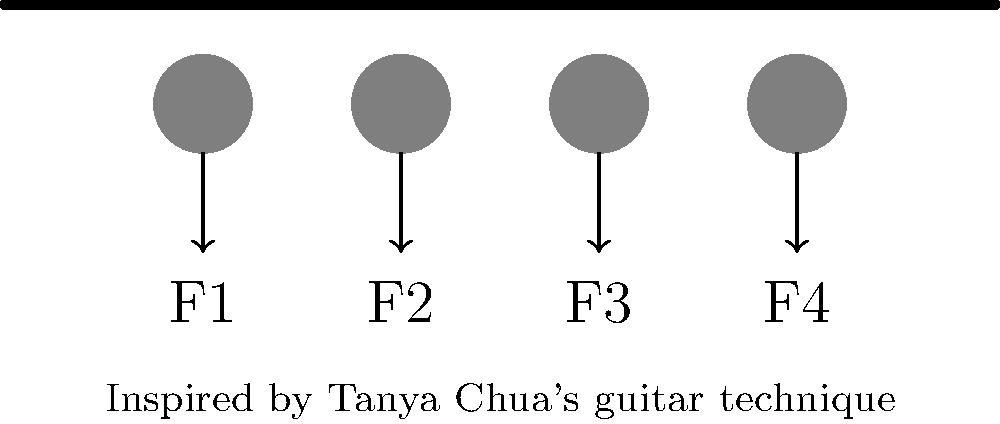In this simplified diagram of a hand position while playing guitar, inspired by Tanya Chua's technique, four fingers are pressing down on the strings. If the total force applied by the hand is 20N, and the force distribution follows the sequence of a geometric progression with a common ratio of 1.5, what is the force (in Newtons) applied by the finger labeled F1? Let's approach this step-by-step:

1) We know that the forces follow a geometric progression with a common ratio of 1.5. Let's call the force applied by F1 as x. Then:

   F1 = x
   F2 = 1.5x
   F3 = 1.5^2 * x = 2.25x
   F4 = 1.5^3 * x = 3.375x

2) The total force is 20N, so we can set up an equation:

   x + 1.5x + 2.25x + 3.375x = 20

3) Simplify the left side of the equation:

   8.125x = 20

4) Solve for x:

   x = 20 / 8.125 = 2.4615...

5) Round to two decimal places:

   x ≈ 2.46N

Therefore, the force applied by the finger labeled F1 is approximately 2.46N.
Answer: 2.46N 